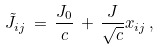<formula> <loc_0><loc_0><loc_500><loc_500>\tilde { J } _ { i j } \, = \, \frac { J _ { 0 } } { c } \, + \, \frac { J } { \sqrt { c } } x _ { i j } \, ,</formula> 